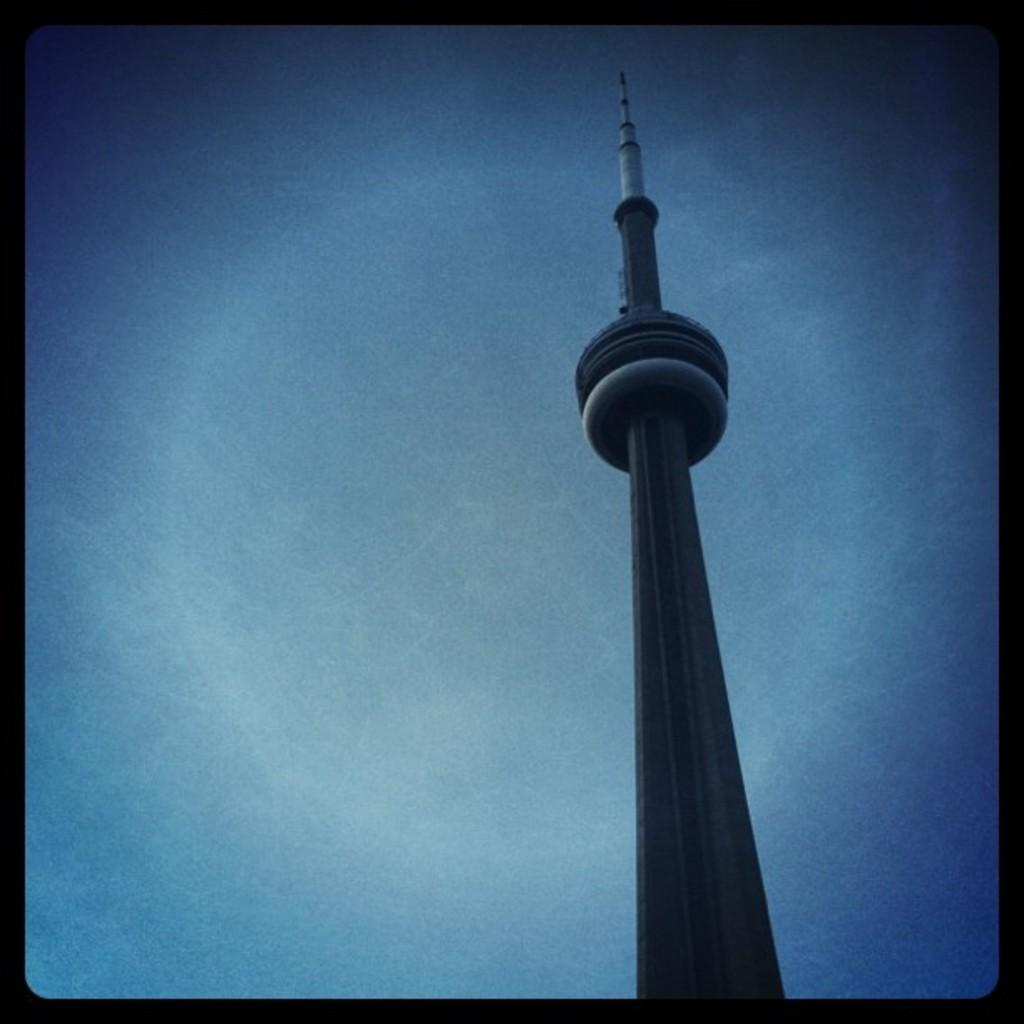What is the main structure in the image? There is a big tower in the image. What can be seen in the background of the image? The background of the image includes the blue sky. How many crackers are placed on the finger in the image? There are no crackers or fingers present in the image; it only features a big tower and the blue sky. 